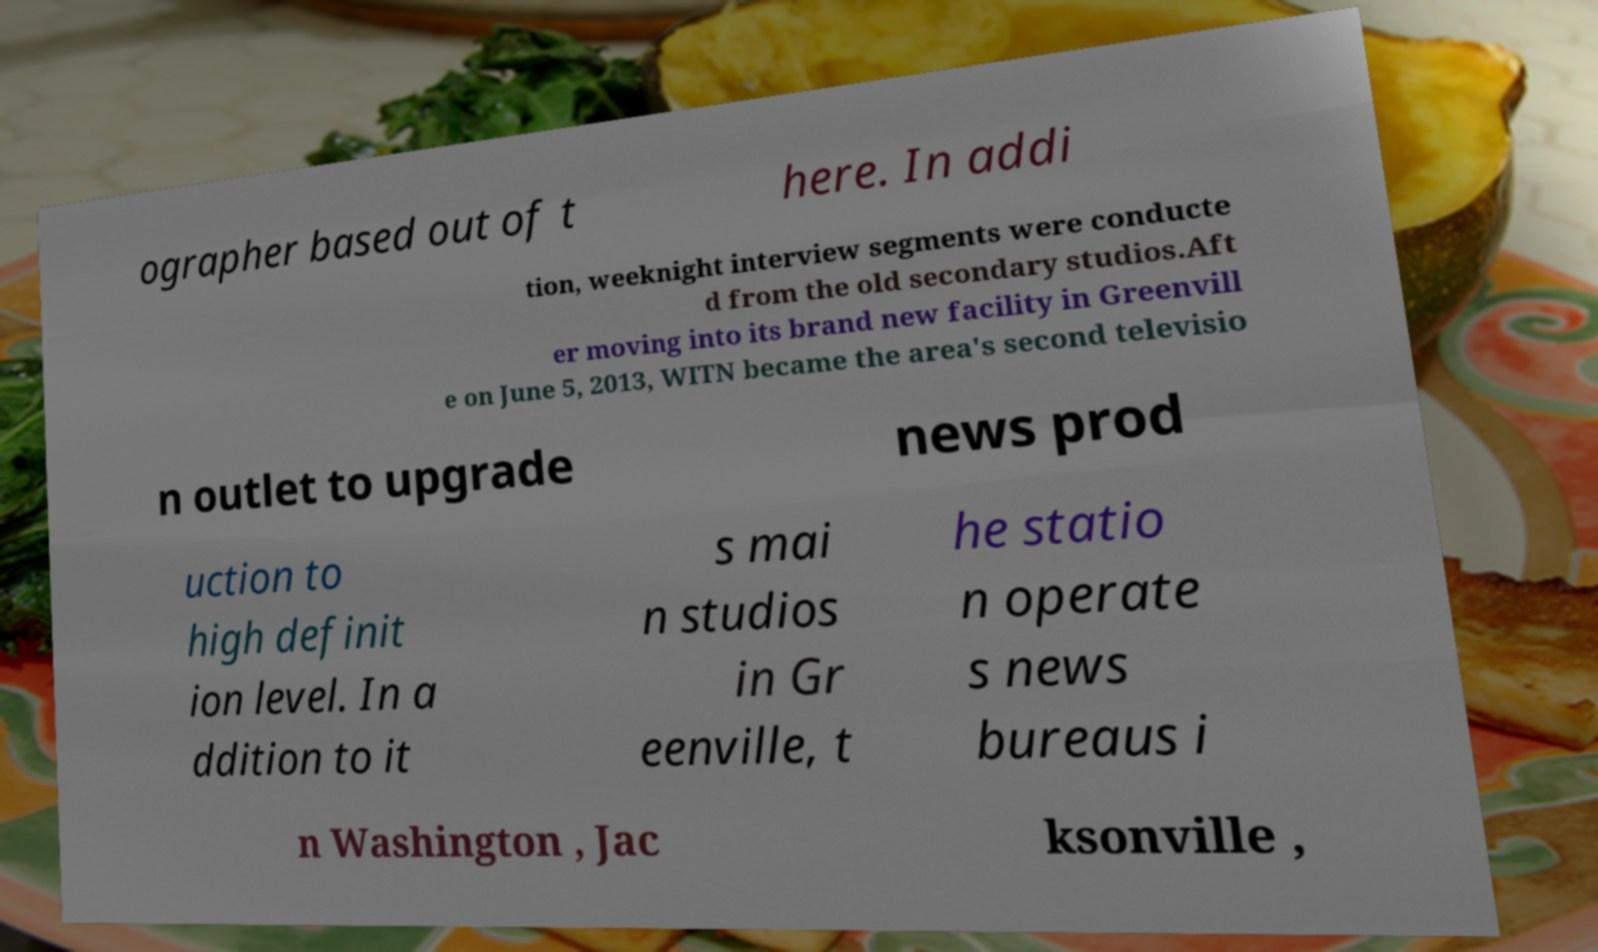There's text embedded in this image that I need extracted. Can you transcribe it verbatim? ographer based out of t here. In addi tion, weeknight interview segments were conducte d from the old secondary studios.Aft er moving into its brand new facility in Greenvill e on June 5, 2013, WITN became the area's second televisio n outlet to upgrade news prod uction to high definit ion level. In a ddition to it s mai n studios in Gr eenville, t he statio n operate s news bureaus i n Washington , Jac ksonville , 